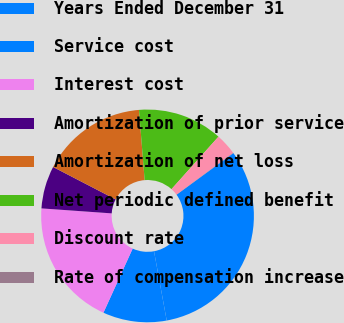Convert chart. <chart><loc_0><loc_0><loc_500><loc_500><pie_chart><fcel>Years Ended December 31<fcel>Service cost<fcel>Interest cost<fcel>Amortization of prior service<fcel>Amortization of net loss<fcel>Net periodic defined benefit<fcel>Discount rate<fcel>Rate of compensation increase<nl><fcel>32.16%<fcel>9.69%<fcel>19.32%<fcel>6.48%<fcel>16.11%<fcel>12.9%<fcel>3.27%<fcel>0.06%<nl></chart> 